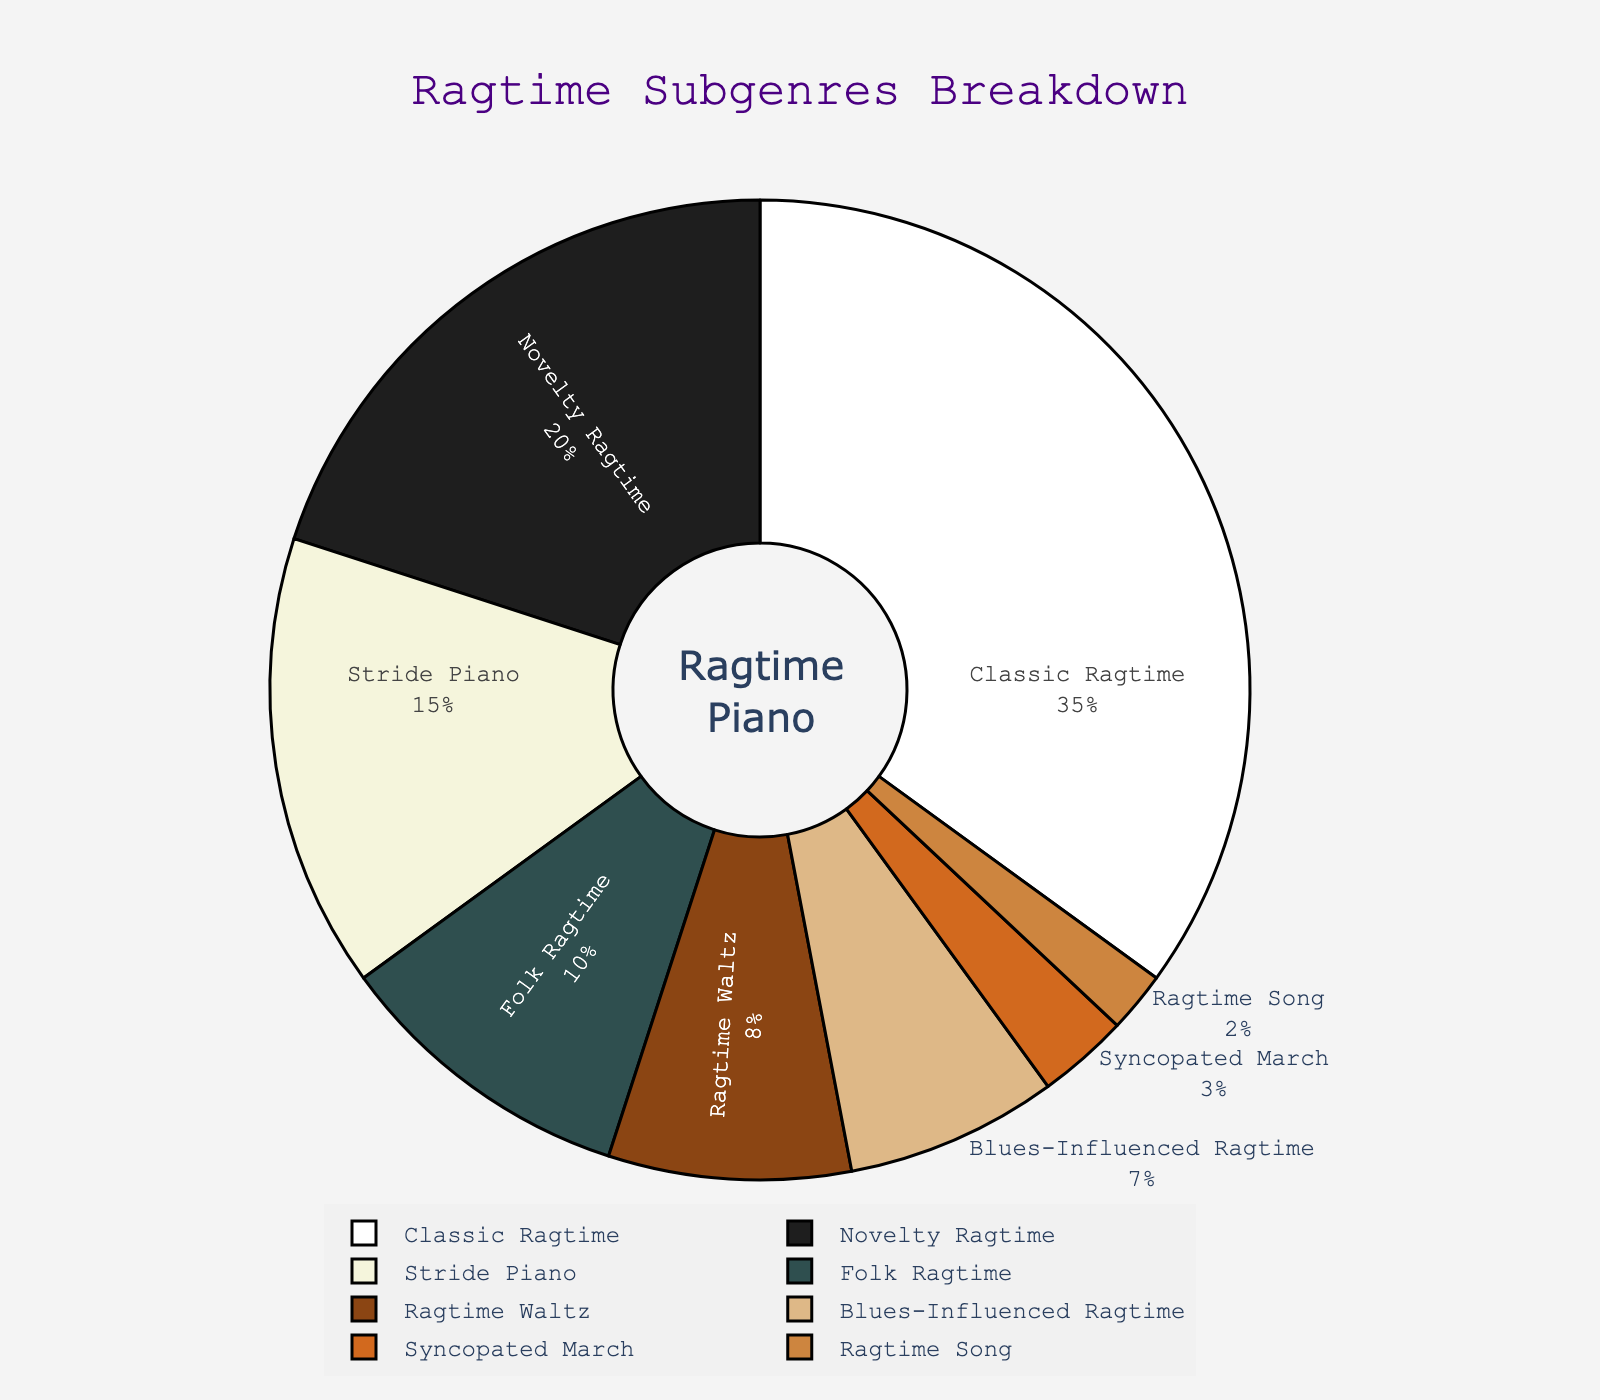What percentage of the chart is covered by Stride Piano and Ragtime Waltz combined? First, find the percentages for Stride Piano (15%) and Ragtime Waltz (8%). Then, add these two percentages together: 15% + 8% = 23%.
Answer: 23% Which subgenre has a larger percentage, Folk Ragtime or Blues-Influenced Ragtime? Compare the percentages given for Folk Ragtime (10%) and Blues-Influenced Ragtime (7%). Since 10% is greater than 7%, Folk Ragtime has a larger percentage.
Answer: Folk Ragtime What is the smallest represented subgenre in the chart? Identify the subgenre with the smallest percentage value by looking at all percentages. The smallest is Ragtime Song with 2%.
Answer: Ragtime Song How much larger is the Classic Ragtime section compared to the Syncopated March section? Identify the percentages of Classic Ragtime (35%) and Syncopated March (3%). Subtract the smaller percentage from the larger one: 35% - 3% = 32%.
Answer: 32% Which subgenre is represented using a darker color and what could it be based on the figure? Given there is no physical figure, assume darker colors might be used for higher percentages or distinguishable sections. The Classic Ragtime, with the highest percentage (35%), could likely have a darker color compared to others.
Answer: Classic Ragtime How many subgenres occupy less than 10% of the chart each? Examine the percentages of each subgenre. The subgenres with less than 10% each are Folk Ragtime (10%), Ragtime Waltz (8%), Blues-Influenced Ragtime (7%), Syncopated March (3%), and Ragtime Song (2%). Count these subgenres to get the result.
Answer: 5 Is the combined percentage of Novelty Ragtime and Ragtime Song greater than Classic Ragtime alone? Find the percentages of Novelty Ragtime (20%) and Ragtime Song (2%). Add these two percentages together: 20% + 2% = 22%. Compare 22% with Classic Ragtime's 35%. Since 22% is less than 35%, the combined percentage is not greater.
Answer: No What percentage is covered by the sum of all subgenres other than Classic Ragtime? Add the percentages of all subgenres except Classic Ragtime: 20% (Novelty Ragtime) + 15% (Stride Piano) + 10% (Folk Ragtime) + 8% (Ragtime Waltz) + 7% (Blues-Influenced Ragtime) + 3% (Syncopated March) + 2% (Ragtime Song) = 65%.
Answer: 65% 